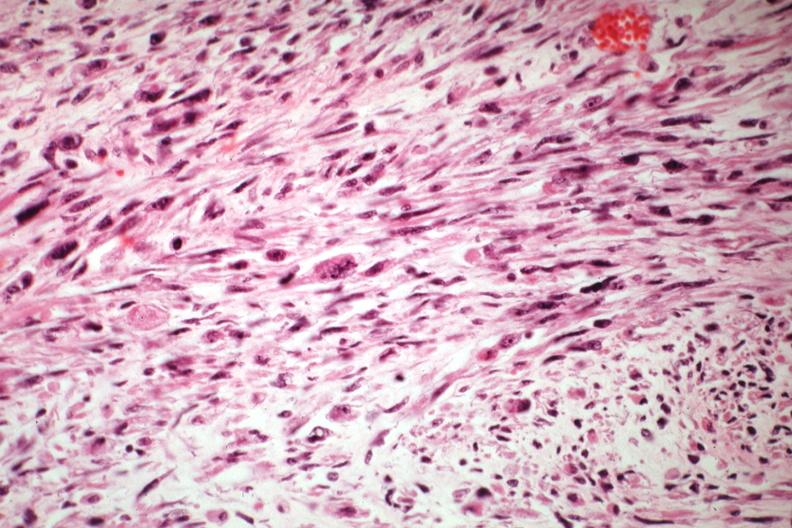s coronary atherosclerosis present?
Answer the question using a single word or phrase. No 